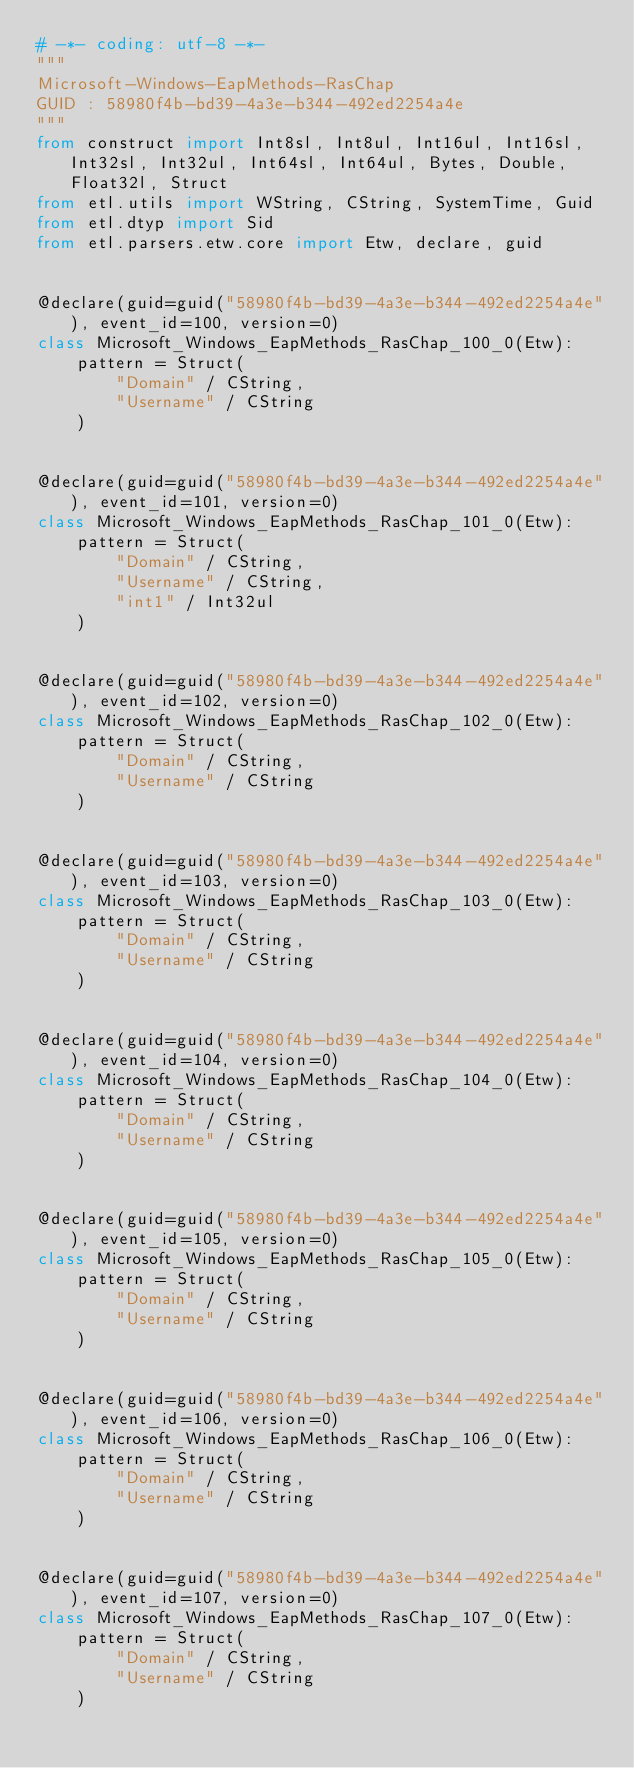Convert code to text. <code><loc_0><loc_0><loc_500><loc_500><_Python_># -*- coding: utf-8 -*-
"""
Microsoft-Windows-EapMethods-RasChap
GUID : 58980f4b-bd39-4a3e-b344-492ed2254a4e
"""
from construct import Int8sl, Int8ul, Int16ul, Int16sl, Int32sl, Int32ul, Int64sl, Int64ul, Bytes, Double, Float32l, Struct
from etl.utils import WString, CString, SystemTime, Guid
from etl.dtyp import Sid
from etl.parsers.etw.core import Etw, declare, guid


@declare(guid=guid("58980f4b-bd39-4a3e-b344-492ed2254a4e"), event_id=100, version=0)
class Microsoft_Windows_EapMethods_RasChap_100_0(Etw):
    pattern = Struct(
        "Domain" / CString,
        "Username" / CString
    )


@declare(guid=guid("58980f4b-bd39-4a3e-b344-492ed2254a4e"), event_id=101, version=0)
class Microsoft_Windows_EapMethods_RasChap_101_0(Etw):
    pattern = Struct(
        "Domain" / CString,
        "Username" / CString,
        "int1" / Int32ul
    )


@declare(guid=guid("58980f4b-bd39-4a3e-b344-492ed2254a4e"), event_id=102, version=0)
class Microsoft_Windows_EapMethods_RasChap_102_0(Etw):
    pattern = Struct(
        "Domain" / CString,
        "Username" / CString
    )


@declare(guid=guid("58980f4b-bd39-4a3e-b344-492ed2254a4e"), event_id=103, version=0)
class Microsoft_Windows_EapMethods_RasChap_103_0(Etw):
    pattern = Struct(
        "Domain" / CString,
        "Username" / CString
    )


@declare(guid=guid("58980f4b-bd39-4a3e-b344-492ed2254a4e"), event_id=104, version=0)
class Microsoft_Windows_EapMethods_RasChap_104_0(Etw):
    pattern = Struct(
        "Domain" / CString,
        "Username" / CString
    )


@declare(guid=guid("58980f4b-bd39-4a3e-b344-492ed2254a4e"), event_id=105, version=0)
class Microsoft_Windows_EapMethods_RasChap_105_0(Etw):
    pattern = Struct(
        "Domain" / CString,
        "Username" / CString
    )


@declare(guid=guid("58980f4b-bd39-4a3e-b344-492ed2254a4e"), event_id=106, version=0)
class Microsoft_Windows_EapMethods_RasChap_106_0(Etw):
    pattern = Struct(
        "Domain" / CString,
        "Username" / CString
    )


@declare(guid=guid("58980f4b-bd39-4a3e-b344-492ed2254a4e"), event_id=107, version=0)
class Microsoft_Windows_EapMethods_RasChap_107_0(Etw):
    pattern = Struct(
        "Domain" / CString,
        "Username" / CString
    )

</code> 